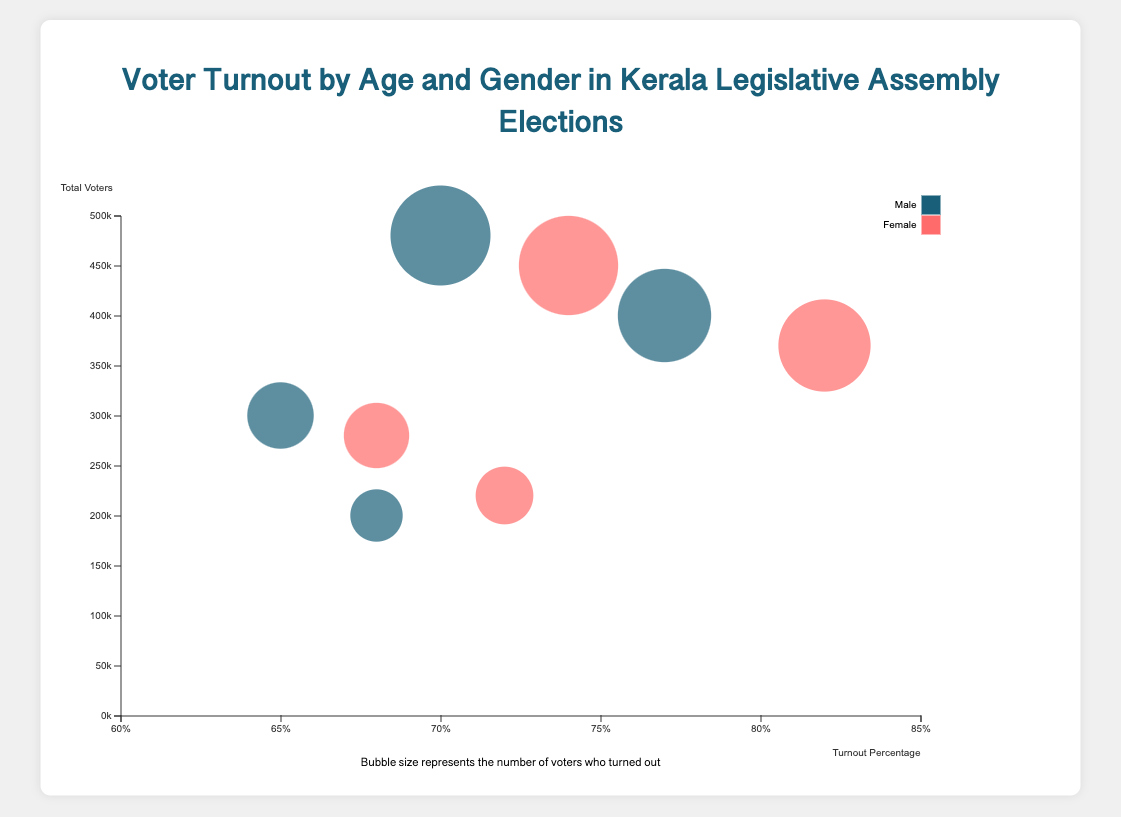What is the title of the chart? The title is usually displayed at the top of the chart. In this case, it is "Voter Turnout by Age and Gender in Kerala Legislative Assembly Elections".
Answer: Voter Turnout by Age and Gender in Kerala Legislative Assembly Elections What does the bubble size represent in the chart? According to the note at the bottom of the chart, the bubble size represents the number of voters who turned out.
Answer: Number of voters who turned out Which age and gender group has the highest voter turnout percentage? The 41-60 age group of females has the highest voter turnout percentage of 82%.
Answer: Females aged 41-60 How many female voters turned out in the 61+ age group? The bubble size for females in the 61+ age group is 158400. This represents the number of female voters who turned out in that group.
Answer: 158,400 Compare the voter turnout percentage of males aged 26-40 with females aged 26-40. Which is higher? The voter turnout percentage for males aged 26-40 is 70%, while for females in the same age range, it is 74%.
Answer: Females aged 26-40 What is the total number of voters in the 18-25 age range? Add the total voters of both genders in the 18-25 age group: 300,000 (male) + 280,000 (female) = 580,000.
Answer: 580,000 How does the voter turnout percentage for males aged 61+ compare to males in the 18-25 age range? The voter turnout percentage for males aged 61+ is 68%, which is higher than the 65% for males in the 18-25 age range.
Answer: Higher Which gender has a higher voter turnout percentage in the 41-60 age range? Females in the 41-60 age range have a turnout percentage of 82%, which is higher than the 77% for males in the same age range.
Answer: Females What is the difference in the number of voters who turned out between males aged 26-40 and females aged 26-40? Subtract the bubble sizes: 336,000 (males) - 333,000 (females) = 3,000.
Answer: 3,000 What can be inferred about the turnout trend as voters age? Analyzing the data, voter turnout percentage generally increases with age until the 41-60 age group and then slightly decreases in the 61+ age group.
Answer: Increases until 41-60, then decreases 